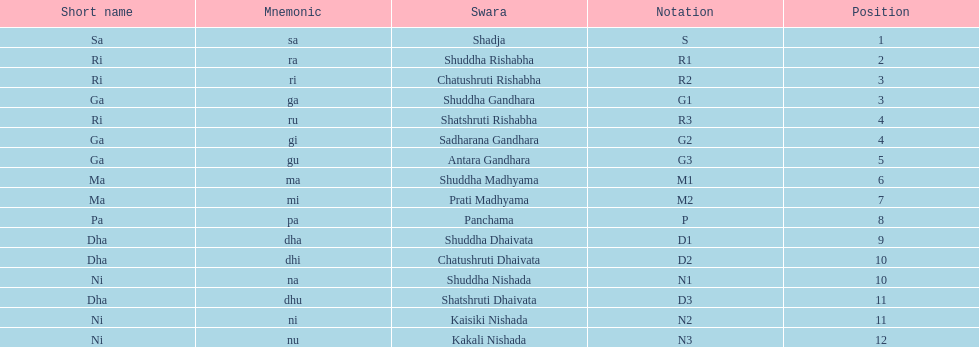How many swaras are without dhaivata in their name? 13. 